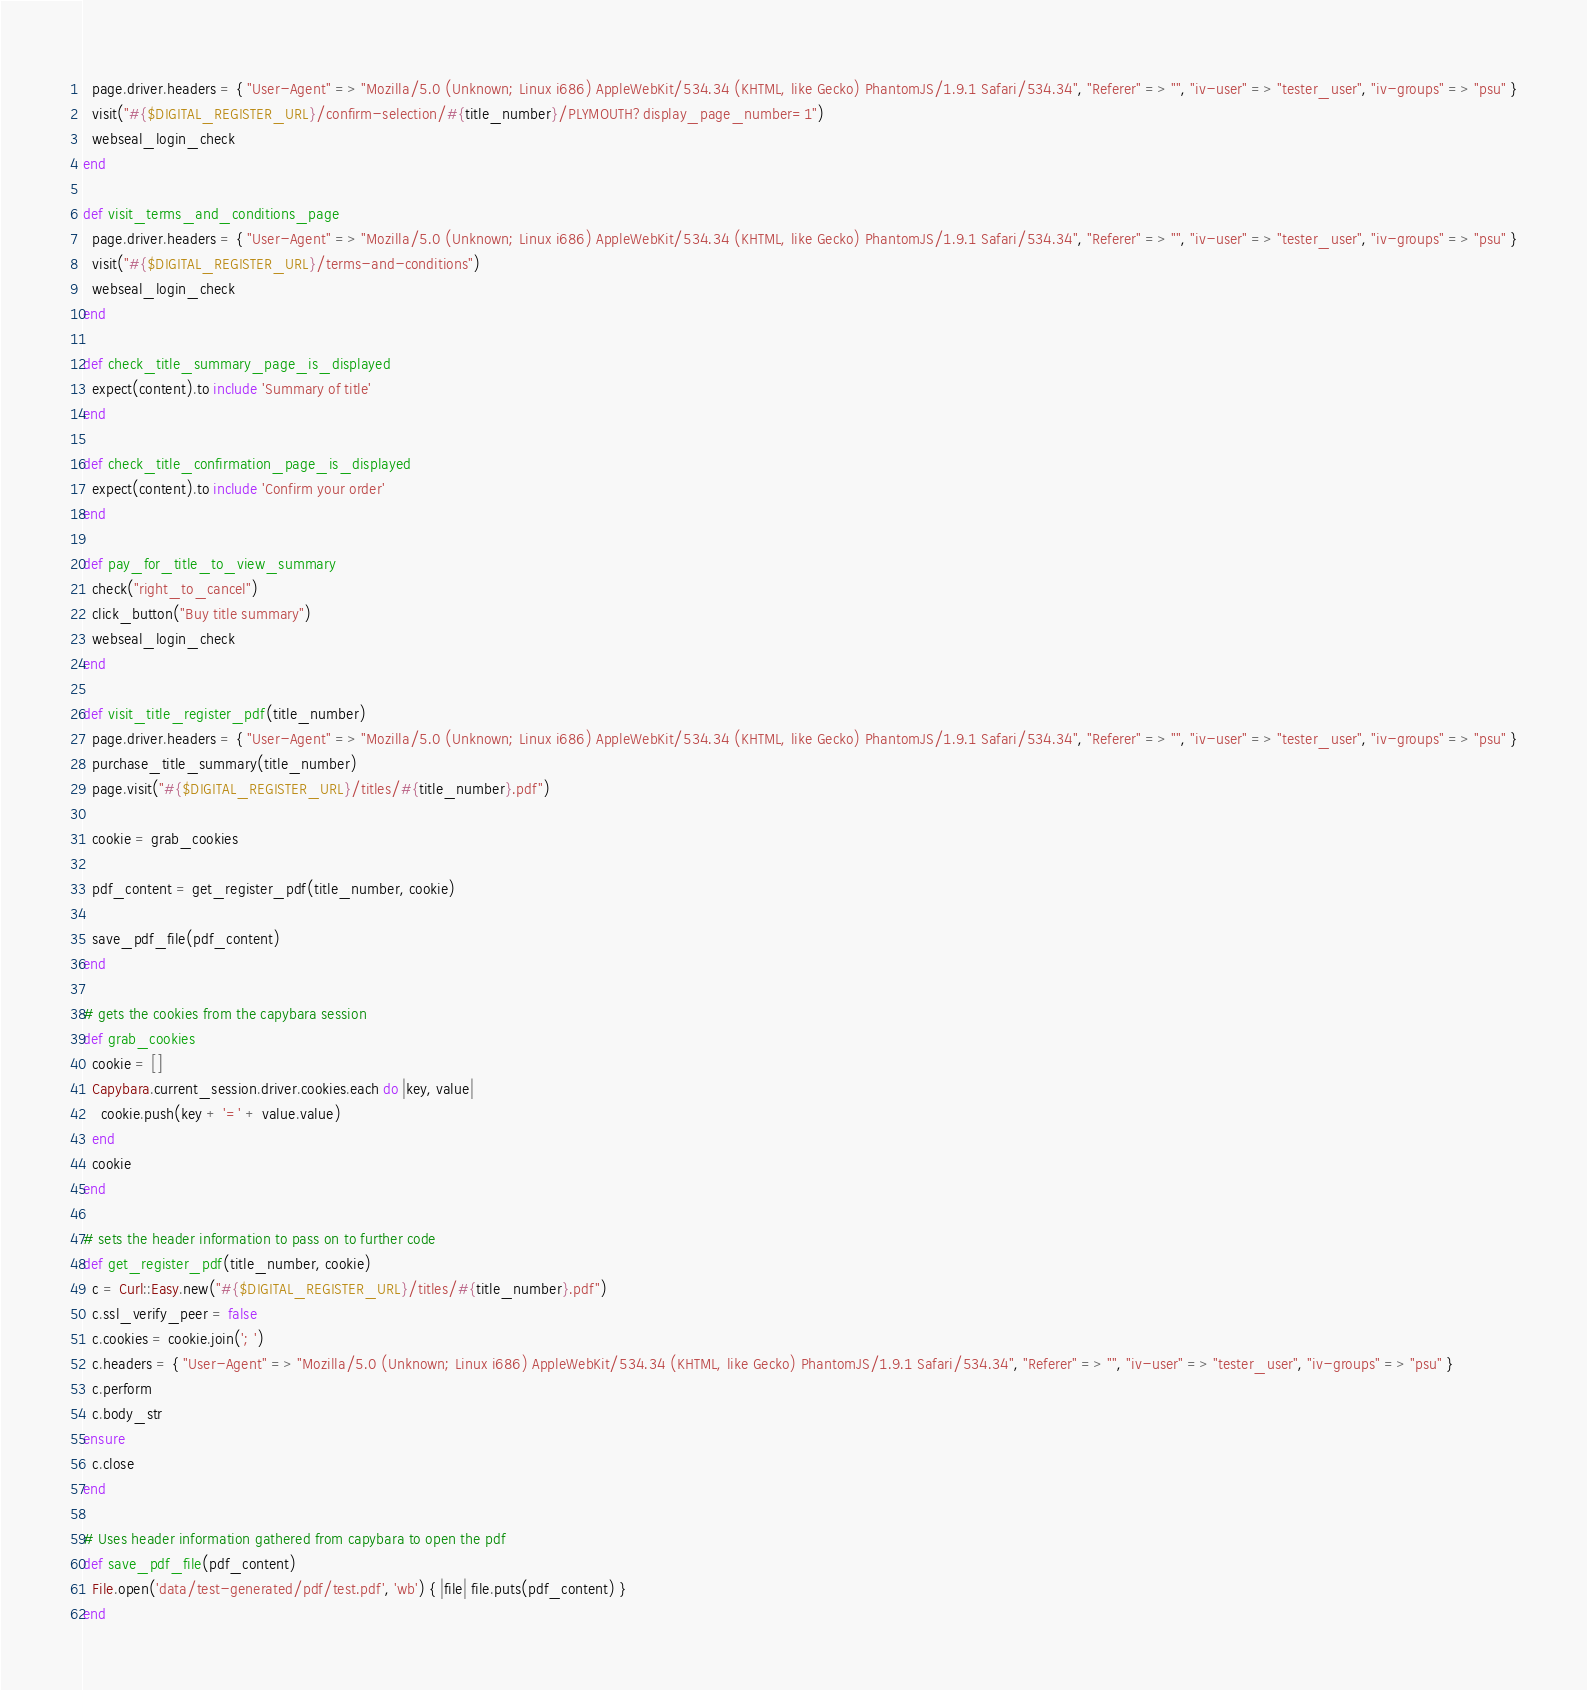<code> <loc_0><loc_0><loc_500><loc_500><_Ruby_>  page.driver.headers = { "User-Agent" => "Mozilla/5.0 (Unknown; Linux i686) AppleWebKit/534.34 (KHTML, like Gecko) PhantomJS/1.9.1 Safari/534.34", "Referer" => "", "iv-user" => "tester_user", "iv-groups" => "psu" }
  visit("#{$DIGITAL_REGISTER_URL}/confirm-selection/#{title_number}/PLYMOUTH?display_page_number=1")
  webseal_login_check
end

def visit_terms_and_conditions_page
  page.driver.headers = { "User-Agent" => "Mozilla/5.0 (Unknown; Linux i686) AppleWebKit/534.34 (KHTML, like Gecko) PhantomJS/1.9.1 Safari/534.34", "Referer" => "", "iv-user" => "tester_user", "iv-groups" => "psu" }
  visit("#{$DIGITAL_REGISTER_URL}/terms-and-conditions")
  webseal_login_check
end

def check_title_summary_page_is_displayed
  expect(content).to include 'Summary of title'
end

def check_title_confirmation_page_is_displayed
  expect(content).to include 'Confirm your order'
end

def pay_for_title_to_view_summary
  check("right_to_cancel")
  click_button("Buy title summary")
  webseal_login_check
end

def visit_title_register_pdf(title_number)
  page.driver.headers = { "User-Agent" => "Mozilla/5.0 (Unknown; Linux i686) AppleWebKit/534.34 (KHTML, like Gecko) PhantomJS/1.9.1 Safari/534.34", "Referer" => "", "iv-user" => "tester_user", "iv-groups" => "psu" }
  purchase_title_summary(title_number)
  page.visit("#{$DIGITAL_REGISTER_URL}/titles/#{title_number}.pdf")

  cookie = grab_cookies

  pdf_content = get_register_pdf(title_number, cookie)

  save_pdf_file(pdf_content)
end

# gets the cookies from the capybara session
def grab_cookies
  cookie = []
  Capybara.current_session.driver.cookies.each do |key, value|
    cookie.push(key + '=' + value.value)
  end
  cookie
end

# sets the header information to pass on to further code
def get_register_pdf(title_number, cookie)
  c = Curl::Easy.new("#{$DIGITAL_REGISTER_URL}/titles/#{title_number}.pdf")
  c.ssl_verify_peer = false
  c.cookies = cookie.join('; ')
  c.headers = { "User-Agent" => "Mozilla/5.0 (Unknown; Linux i686) AppleWebKit/534.34 (KHTML, like Gecko) PhantomJS/1.9.1 Safari/534.34", "Referer" => "", "iv-user" => "tester_user", "iv-groups" => "psu" }
  c.perform
  c.body_str
ensure
  c.close
end

# Uses header information gathered from capybara to open the pdf
def save_pdf_file(pdf_content)
  File.open('data/test-generated/pdf/test.pdf', 'wb') { |file| file.puts(pdf_content) }
end
</code> 